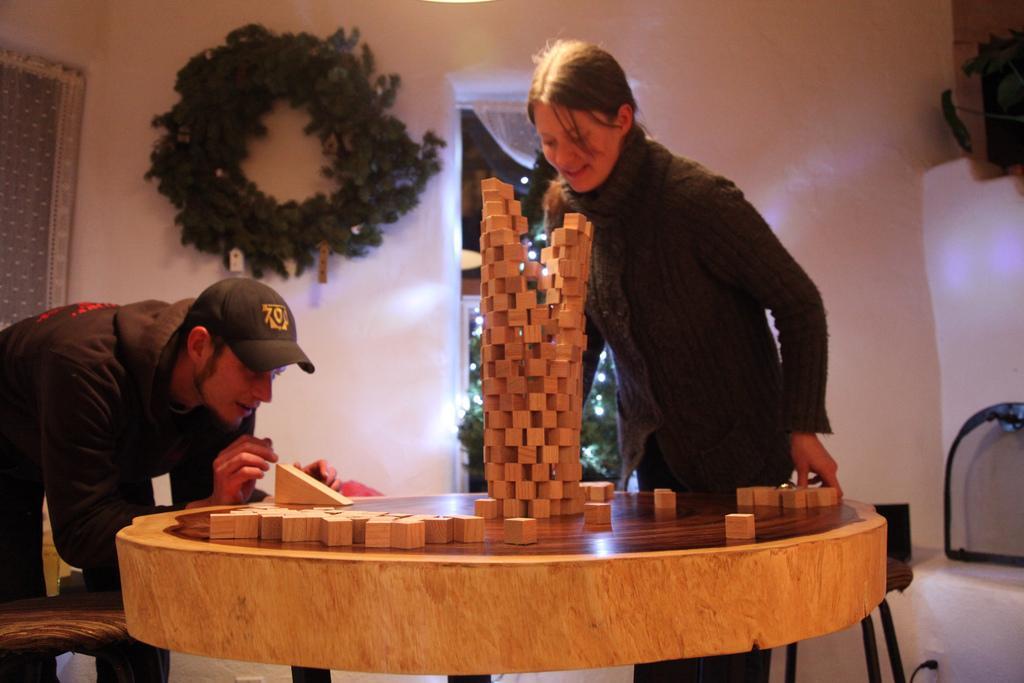Could you give a brief overview of what you see in this image? In this image I see a man who is wearing a cap and a woman who is standing over here and I can also see that there is a table in front and there are a lot of blocks on it. In the background I see the wall, door and the decoration. 